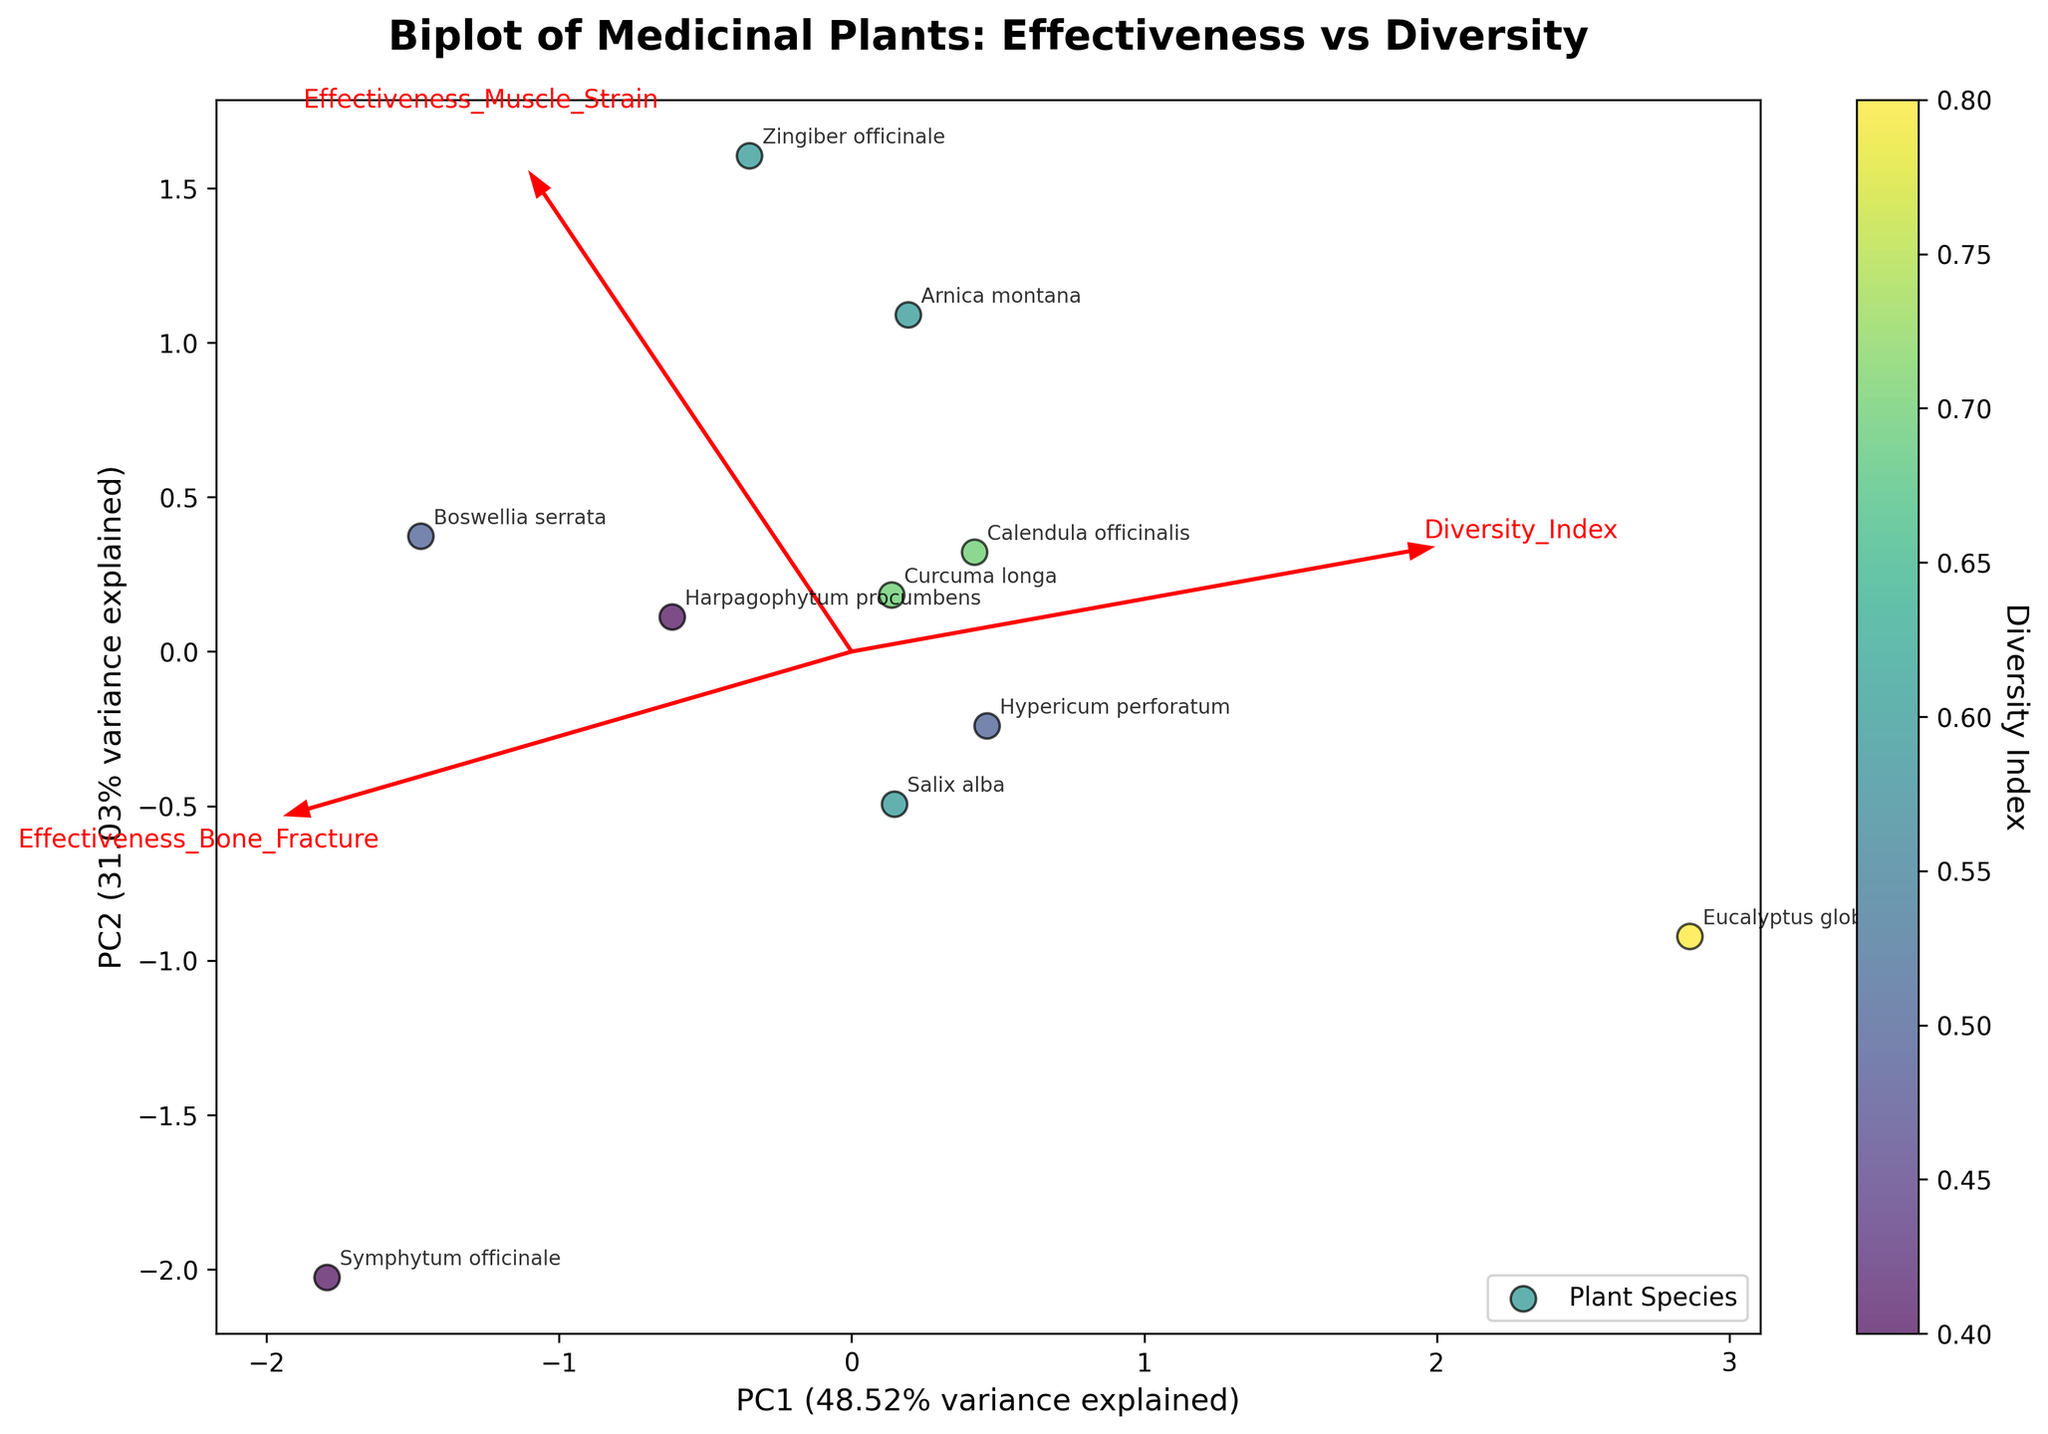What are the axes labeled? The x-axis is labeled as 'PC1' and the y-axis is labeled as 'PC2'. These represent the first principal component and the second principal component respectively, along with the percentage of variance they explain.
Answer: PC1 and PC2 How many plant species are plotted in the biplot? There are 10 different plant species plotted, as indicated by the points and their annotations in the biplot.
Answer: 10 Which plant species has the highest diversity index? By examining the color gradient mapped to the diversity index, Eucalyptus globulus shows the most intense color correlating with the highest diversity index.
Answer: Eucalyptus globulus Do muscle strain and bone fracture effectiveness vectors point in similar directions? The arrows for 'Effectiveness_Muscle_Strain' and 'Effectiveness_Bone_Fracture' roughly point in different directions, indicating that these two variables are not highly correlated in the principal component space.
Answer: No Which principal component explains more variance in the data? The x-axis (PC1) shows a higher percentage of variance explained compared to the y-axis (PC2), as indicated by their respective labels.
Answer: PC1 What is the relationship between the plants 'Hypericum perforatum' and 'Zingiber officinale' based on the biplot? 'Hypericum perforatum' and 'Zingiber officinale' are positioned relatively far from each other on the biplot, indicating differences in their profiles based on the principal components.
Answer: They are different Which variable has the greatest influence on PC1? The length of the arrow for 'Effectiveness_Muscle_Strain' in the direction of PC1 is the longest, suggesting it has the most influence on PC1.
Answer: Effectiveness_Muscle_Strain Does 'Symphytum officinale' have higher effectiveness in treating bone fractures compared to muscle strains? 'Symphytum officinale' is closer to the arrow for 'Effectiveness_Bone_Fracture' than 'Effectiveness_Muscle_Strain' in the biplot, indicating higher effectiveness in treating bone fractures.
Answer: Yes Which two plant species are most similar based on the biplot? 'Zingiber officinale' and 'Arnica montana' are positioned closest to each other on the biplot, implying similar profiles in terms of the principal components.
Answer: Zingiber officinale and Arnica montana How is 'Diversity_Index' visually represented in the biplot? 'Diversity_Index' is represented through a color gradient, with different shades indicating different values of the index.
Answer: Color gradient 